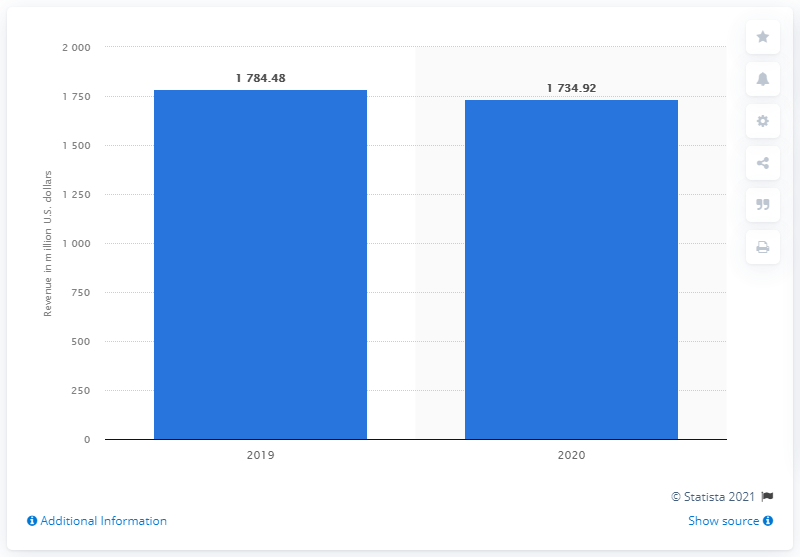Specify some key components in this picture. As of 2020, Aaron's, Inc. operated 1,734.92 stores. In 2020, Aaron's, Inc. generated approximately 1734.92 million in revenue. 